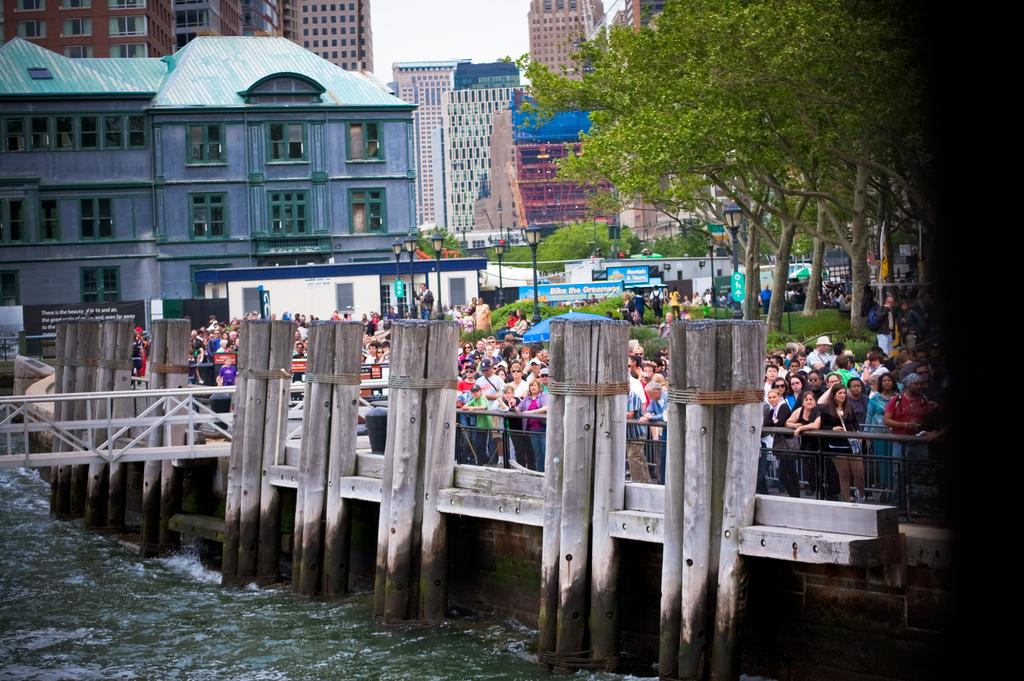What is the main structure in the image? There is a bridge in the image. What is happening around the bridge? The area around the bridge is crowded with people. What can be seen in the backdrop of the image? There are trees and buildings in the backdrop of the image. What type of headwear is the person wearing in the image? There is no person wearing any headwear in the image; it only shows a bridge, a crowded area, and the backdrop with trees and buildings. 